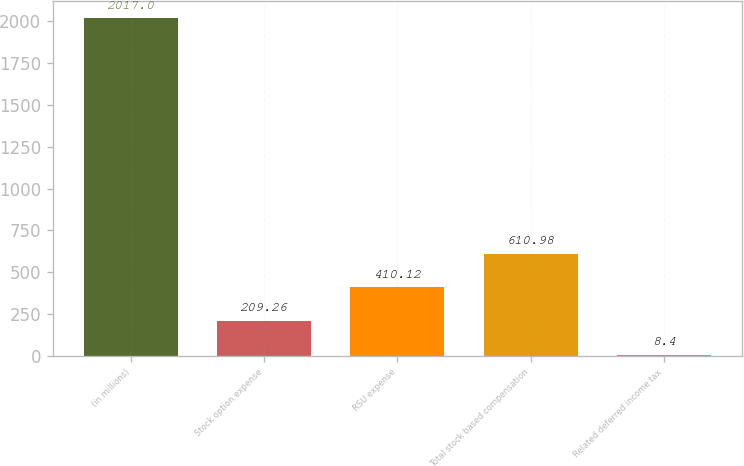Convert chart. <chart><loc_0><loc_0><loc_500><loc_500><bar_chart><fcel>(in millions)<fcel>Stock option expense<fcel>RSU expense<fcel>Total stock based compensation<fcel>Related deferred income tax<nl><fcel>2017<fcel>209.26<fcel>410.12<fcel>610.98<fcel>8.4<nl></chart> 